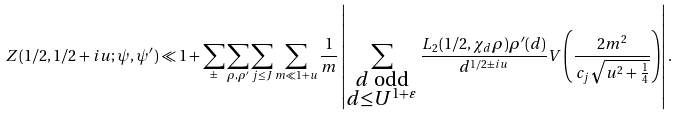Convert formula to latex. <formula><loc_0><loc_0><loc_500><loc_500>Z ( 1 / 2 , 1 / 2 + i u ; \psi , \psi ^ { \prime } ) \ll 1 + \sum _ { \pm } \sum _ { \rho , \rho ^ { \prime } } \sum _ { j \leq J } \sum _ { m \ll 1 + u } \frac { 1 } { m } \left | \sum _ { \substack { d \text { odd} \\ d \leq U ^ { 1 + \varepsilon } } } \frac { L _ { 2 } ( 1 / 2 , \chi _ { d } \rho ) \rho ^ { \prime } ( d ) } { d ^ { 1 / 2 \pm i u } } V \left ( \frac { 2 m ^ { 2 } } { c _ { j } \sqrt { u ^ { 2 } + \frac { 1 } { 4 } } } \right ) \right | .</formula> 